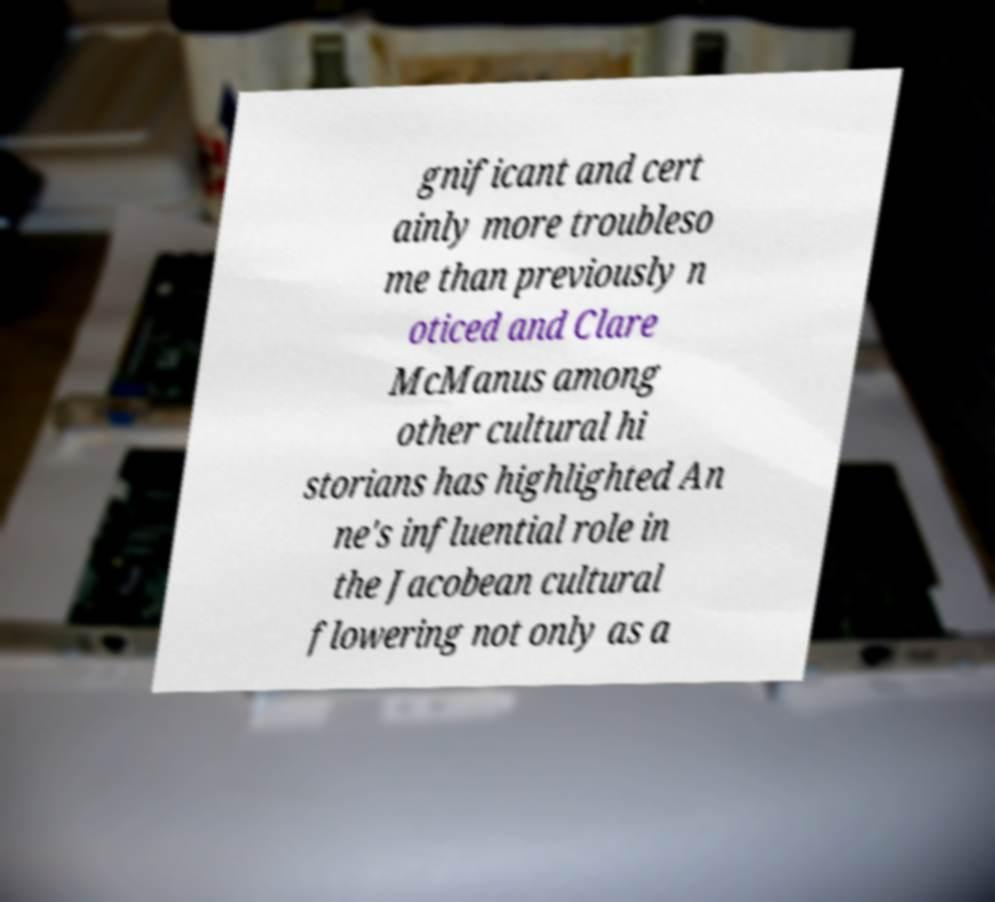Can you accurately transcribe the text from the provided image for me? gnificant and cert ainly more troubleso me than previously n oticed and Clare McManus among other cultural hi storians has highlighted An ne's influential role in the Jacobean cultural flowering not only as a 